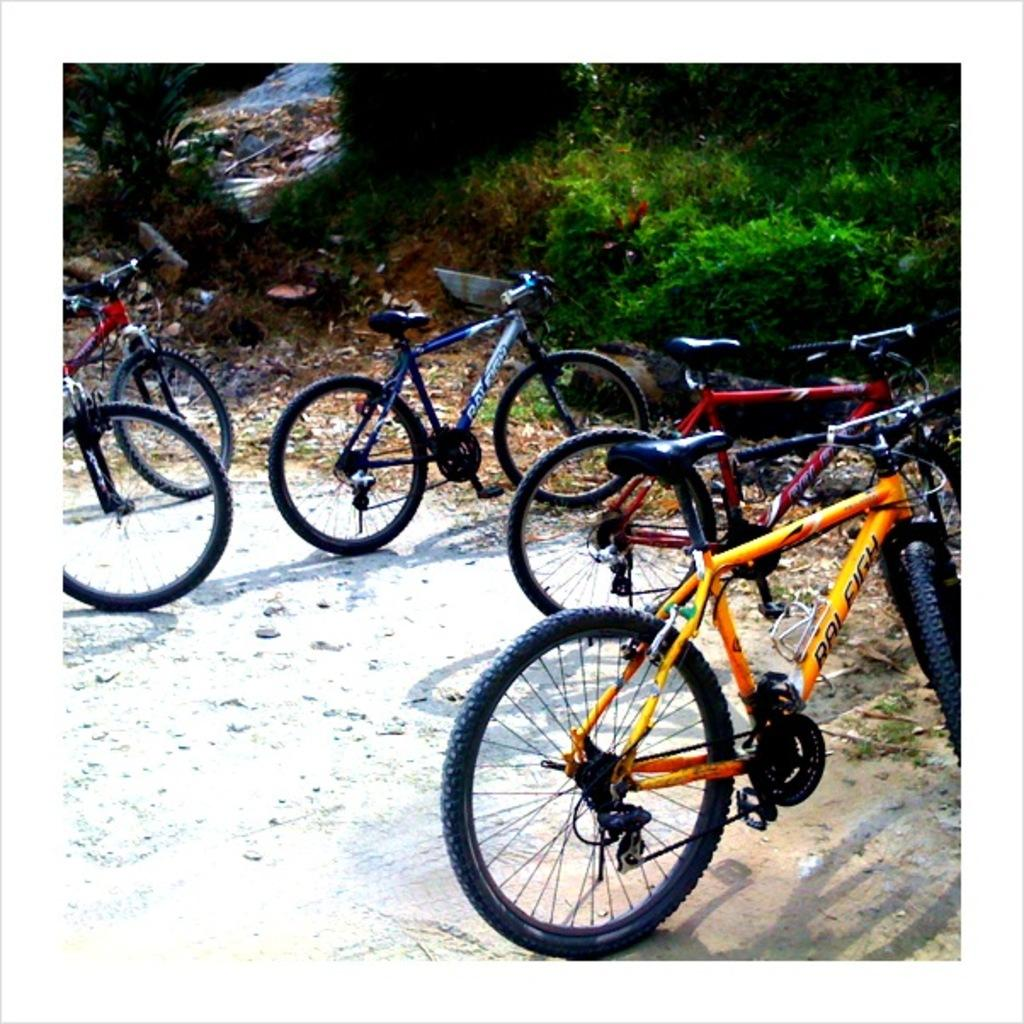What type of vehicles can be seen on the road in the image? There are bicycles on the road in the image. What can be seen in the distance behind the bicycles? There are trees visible in the background of the image. Is there any waste visible in the image? Yes, there is a waste (possibly a waste bin or a pile of waste) in the background of the image. What color is the paint on the bicycles in the image? There is no information about the color of the paint on the bicycles in the image. Is there any snow visible in the image, indicating a winter scene? No, there is no snow visible in the image, and no information about the season. Is there any fire visible in the image? No, there is no fire visible in the image. 